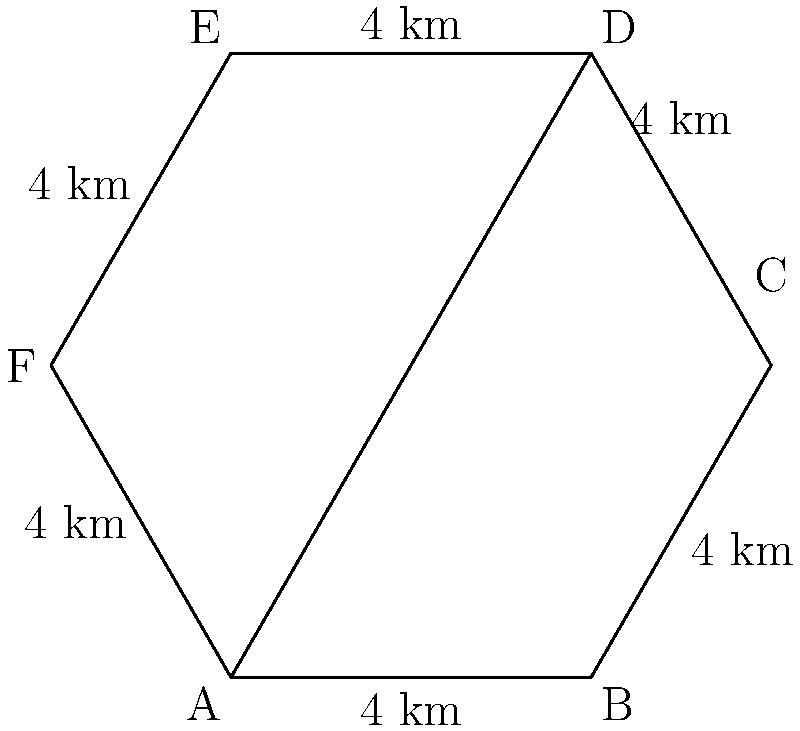As a former PLAAF pilot, you're tasked with calculating the area of a new hexagonal airbase layout. The airbase is a regular hexagon with each side measuring 4 km. What is the total area of the airbase in square kilometers? To calculate the area of a regular hexagon, we can use the formula:

$$A = \frac{3\sqrt{3}}{2}s^2$$

Where $A$ is the area and $s$ is the length of one side.

Given:
- The airbase is a regular hexagon
- Each side measures 4 km

Steps:
1) Substitute $s = 4$ into the formula:

   $$A = \frac{3\sqrt{3}}{2}(4)^2$$

2) Simplify:
   
   $$A = \frac{3\sqrt{3}}{2}(16)$$
   
   $$A = 24\sqrt{3}$$

3) Calculate the approximate value:
   
   $$A \approx 24 \times 1.732 \approx 41.57 \text{ km}^2$$

Therefore, the total area of the hexagonal airbase is approximately 41.57 square kilometers.
Answer: 41.57 km² 